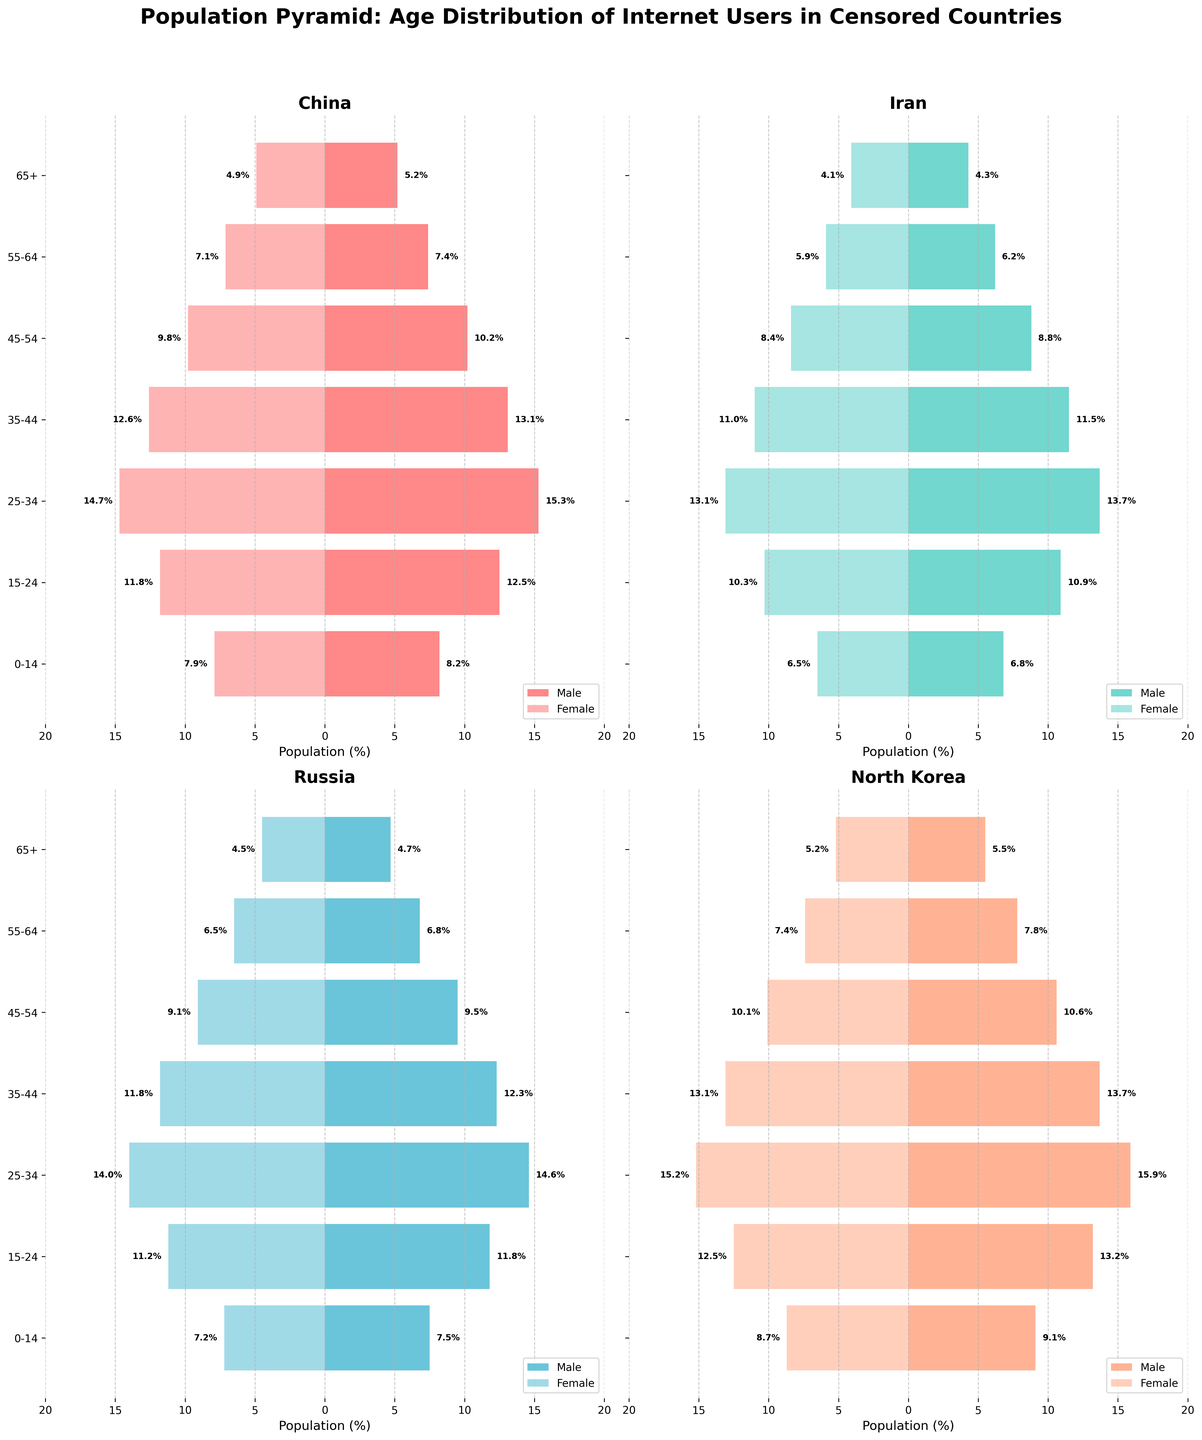Which country has the highest percentage of internet users aged 25-34? To determine this, look at the values on the horizontal bars for the age group 25-34 in each country's plot. North Korea has the highest percentages for both males (15.9%) and females (15.2%) in this age group.
Answer: North Korea What is the male to female ratio in the 35-44 age group for Iran? Add the male and female percentages for Iran's 35-44 age group: Male (11.5%) + Female (11%) = 22.5%. The male ratio can be found by dividing males by the total percentage and the same for females: 11.5/22.5 ≈ 0.51 for males and 11/22.5 ≈ 0.49 for females.
Answer: 51:49 Which country has the smallest difference in internet usage between males and females in any age group? Check each country's bar lengths in different age groups. For the 65+ age group, both males (4.7%) and females (4.5%) in Russia show the smallest difference of 0.2%.
Answer: Russia In North Korea, how does internet usage of the 0-14 age group compare to the 55-64 age group for both genders? Compare the bar lengths for the 0-14 and 55-64 age groups. For males: 0-14 (9.1%) and 55-64 (7.8%). For females: 0-14 (8.7%) and 55-64 (7.4%). Both groups see higher usage in the younger age group with differences of 1.3% and 1.3% respectively.
Answer: Higher in 0-14 What is the total percentage of internet users aged 65+ in all four countries combined? Add the percentages for the 65+ age group for all countries: Male (5.2+4.3+4.7+5.5) + Female (4.9+4.1+4.5+5.2) = 30.4%.
Answer: 30.4% Which country shows the least internet usage for females aged 15-24? Look at the female bars for the 15-24 age group. Iran has the lowest at 10.3%.
Answer: Iran How does the internet usage of Russia's 25-34 age group compare to China's same age group? Compare the bars: Males in Russia (14.6%) vs. China (15.3%), and for females: Russia (14%) vs. China (14.7%). Both genders show higher usage in China.
Answer: Higher in China In which country does the female internet usage consistently lag behind males in each age group? Compare all age groups for disparity between male and female usage. North Korea shows a consistent lag in female usage percentages compared to males in each age group.
Answer: North Korea 